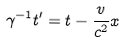Convert formula to latex. <formula><loc_0><loc_0><loc_500><loc_500>\gamma ^ { - 1 } t ^ { \prime } = t - \frac { v } { c ^ { 2 } } x</formula> 